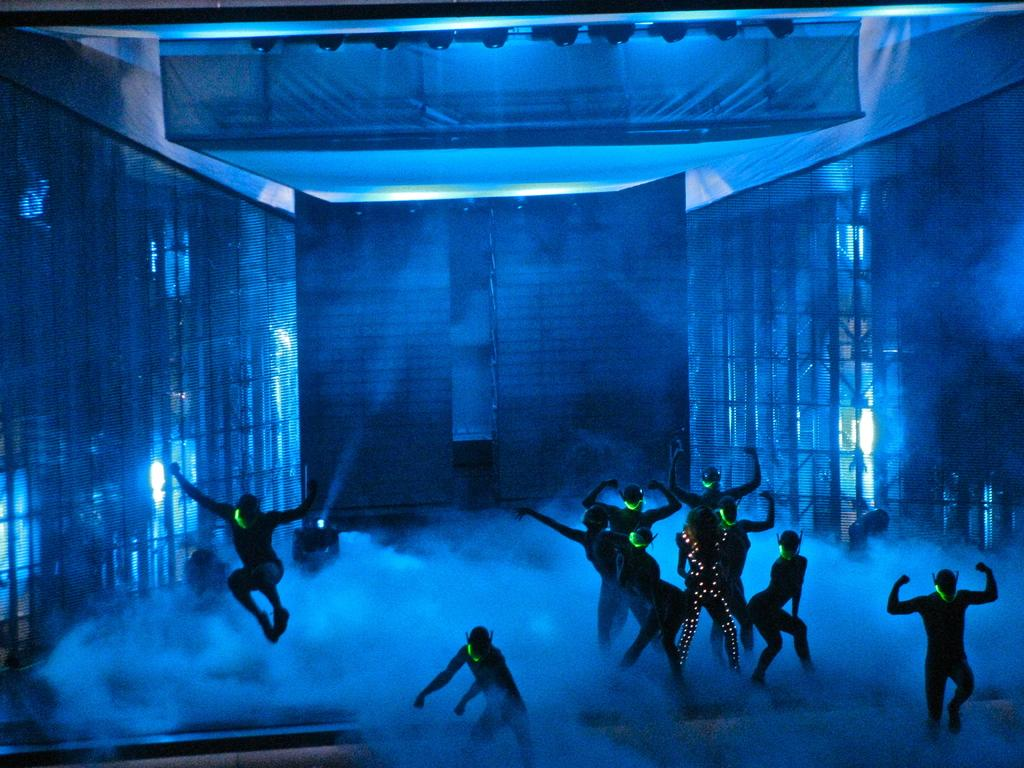Who is present in the image? There are people in the image. What are the people wearing? The people are wearing costumes. What are the people doing in the image? The people are dancing on a stage. Who is watching the people dance? There is an audience in the image. What type of teeth can be seen on the dinosaurs in the image? There are no dinosaurs present in the image, so there are no teeth to observe. 